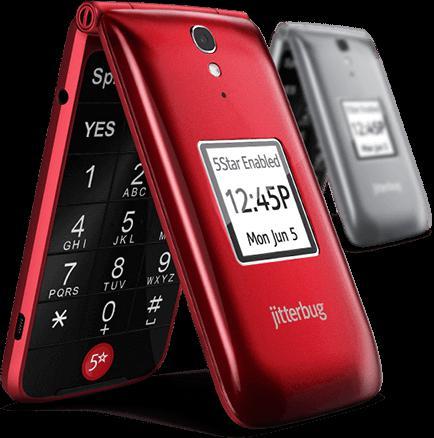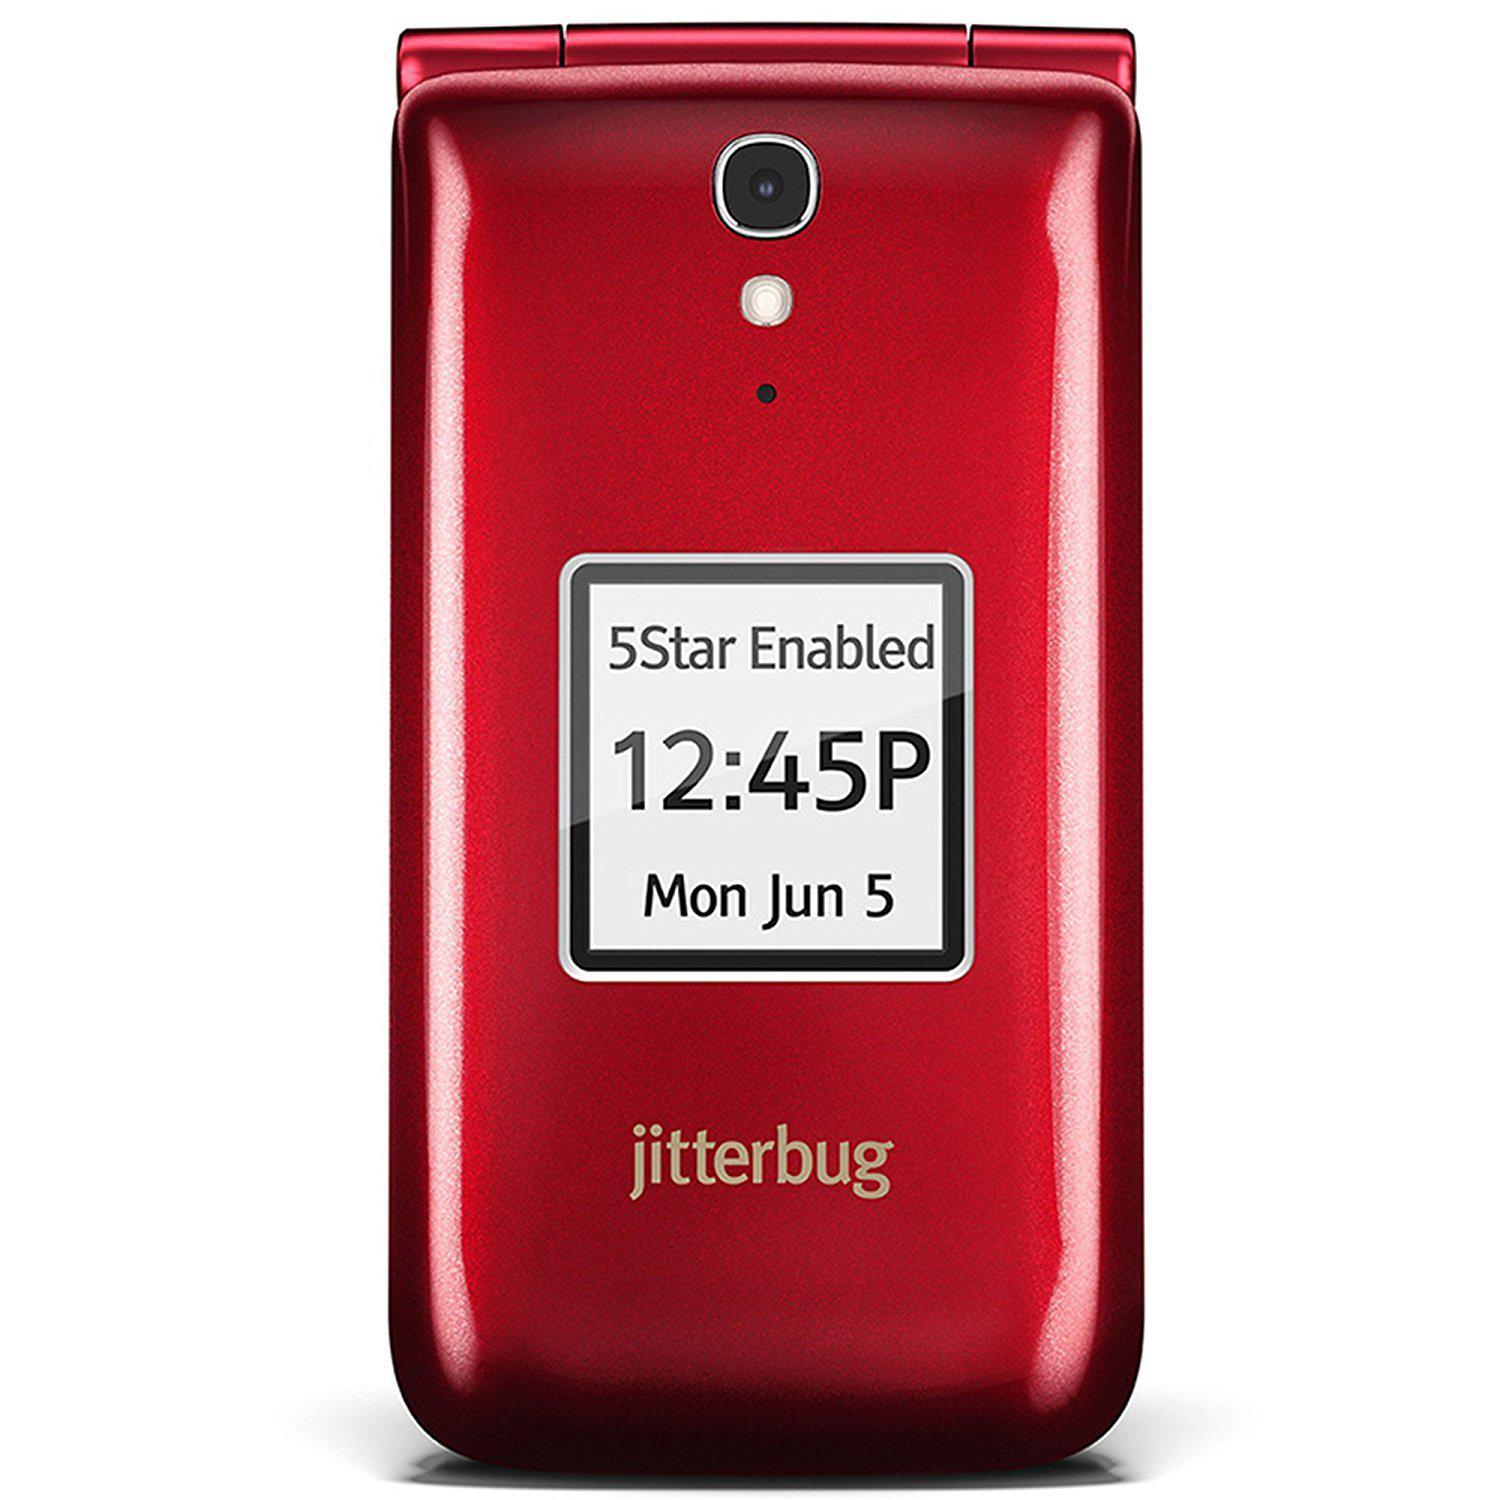The first image is the image on the left, the second image is the image on the right. Analyze the images presented: Is the assertion "Each phone is the same model" valid? Answer yes or no. Yes. The first image is the image on the left, the second image is the image on the right. Assess this claim about the two images: "One image shows a head-on open flip phone next to a closed phone, and the other image shows a single phone displayed upright and headon.". Correct or not? Answer yes or no. No. 